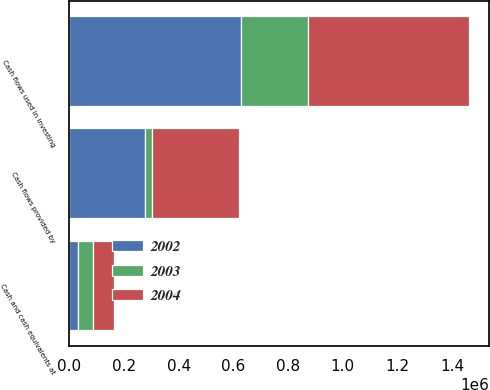Convert chart. <chart><loc_0><loc_0><loc_500><loc_500><stacked_bar_chart><ecel><fcel>Cash flows provided by<fcel>Cash flows used in investing<fcel>Cash and cash equivalents at<nl><fcel>2003<fcel>27098<fcel>247757<fcel>56292<nl><fcel>2004<fcel>315054<fcel>586634<fcel>74683<nl><fcel>2002<fcel>276569<fcel>626523<fcel>31942<nl></chart> 